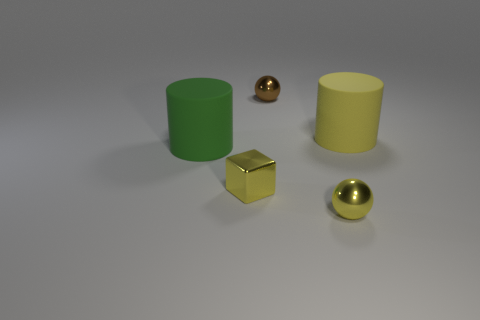Do the large thing behind the green rubber cylinder and the ball that is behind the big yellow cylinder have the same material?
Offer a terse response. No. What shape is the metallic thing left of the tiny metallic object that is behind the thing left of the small metal block?
Provide a short and direct response. Cube. Are there more brown metal balls than blue matte spheres?
Ensure brevity in your answer.  Yes. Are any objects visible?
Provide a short and direct response. Yes. What number of objects are tiny shiny spheres right of the brown metallic sphere or shiny balls that are behind the large green thing?
Offer a very short reply. 2. Is the number of green matte objects less than the number of metal balls?
Offer a terse response. Yes. Are there any large yellow rubber cylinders right of the green cylinder?
Your answer should be compact. Yes. Is the small brown ball made of the same material as the cube?
Make the answer very short. Yes. There is another small object that is the same shape as the small brown metal thing; what is its color?
Your answer should be very brief. Yellow. Does the large matte object that is right of the small yellow block have the same color as the shiny block?
Give a very brief answer. Yes. 